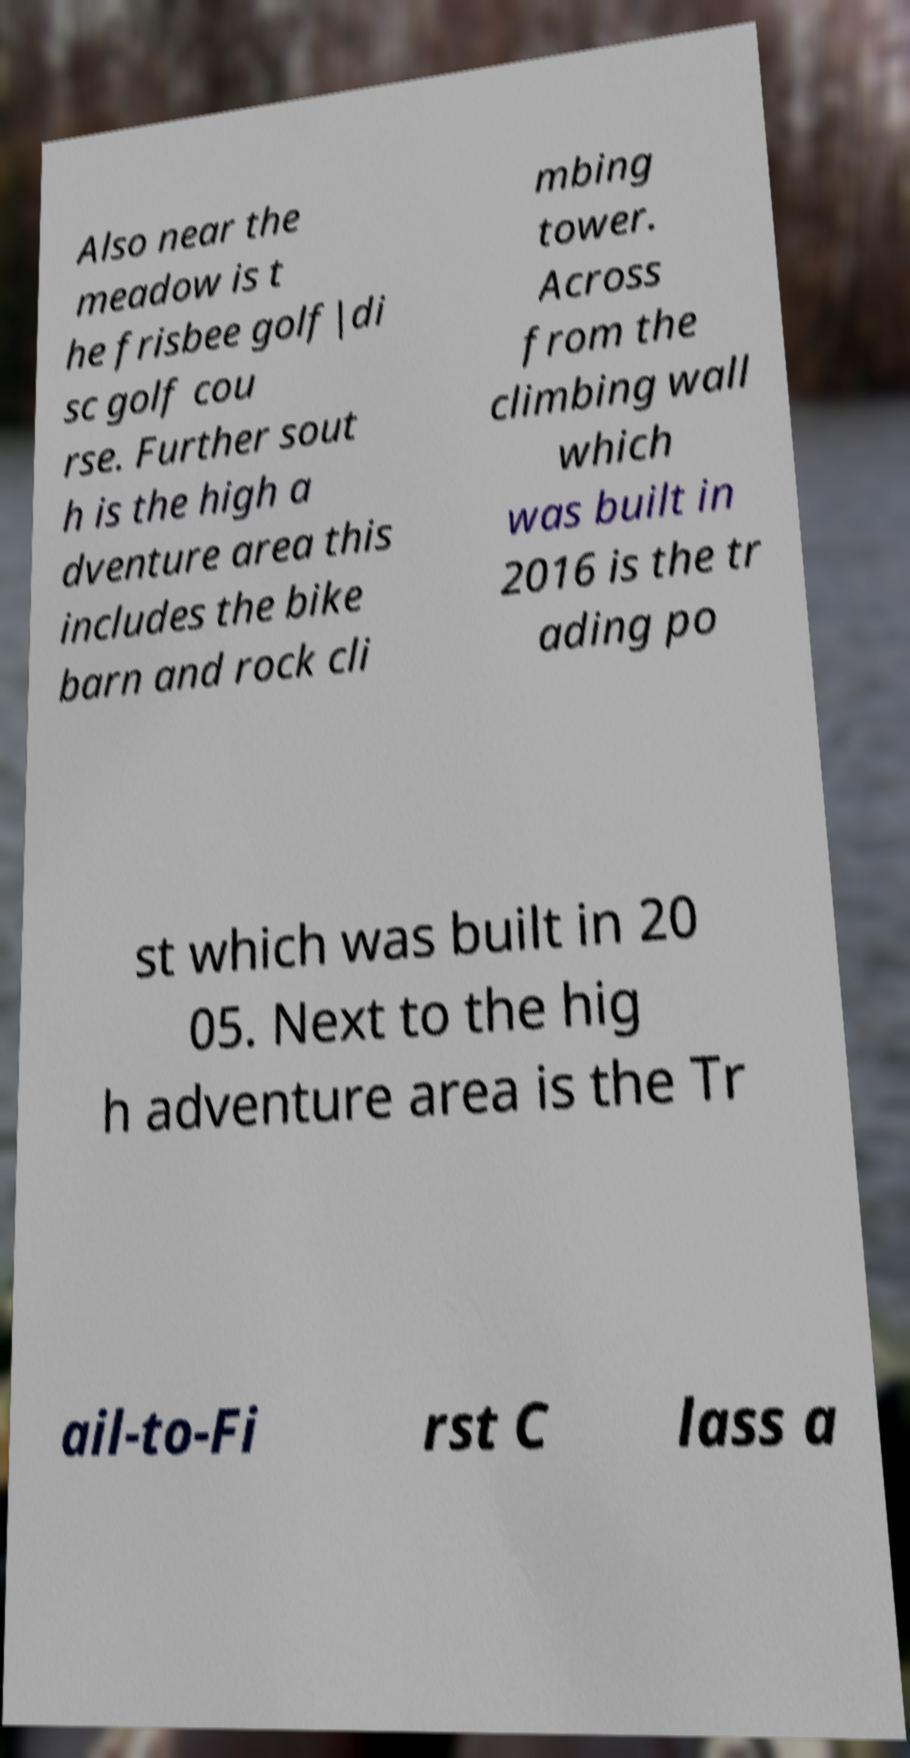Can you accurately transcribe the text from the provided image for me? Also near the meadow is t he frisbee golf|di sc golf cou rse. Further sout h is the high a dventure area this includes the bike barn and rock cli mbing tower. Across from the climbing wall which was built in 2016 is the tr ading po st which was built in 20 05. Next to the hig h adventure area is the Tr ail-to-Fi rst C lass a 